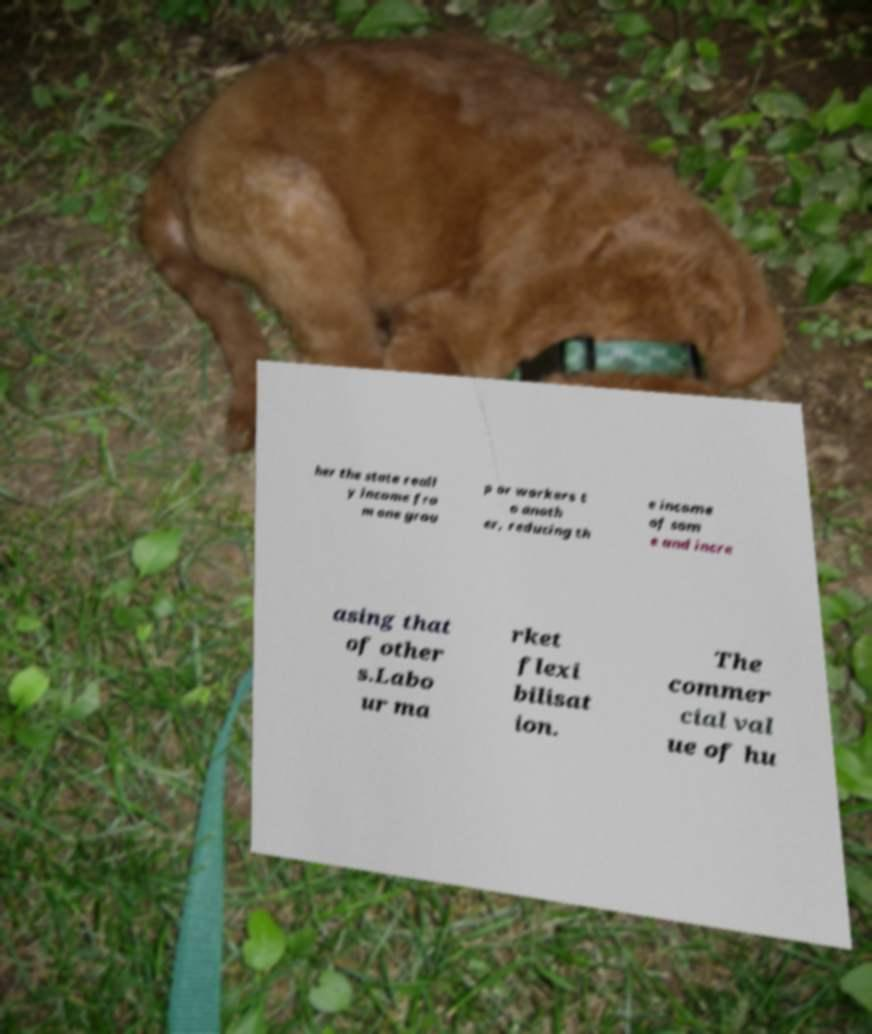Please read and relay the text visible in this image. What does it say? her the state reall y income fro m one grou p or workers t o anoth er, reducing th e income of som e and incre asing that of other s.Labo ur ma rket flexi bilisat ion. The commer cial val ue of hu 